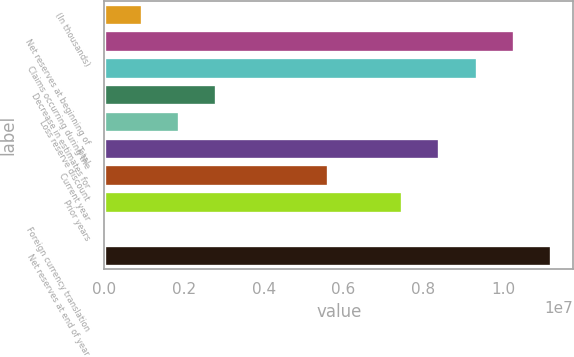<chart> <loc_0><loc_0><loc_500><loc_500><bar_chart><fcel>(In thousands)<fcel>Net reserves at beginning of<fcel>Claims occurring during the<fcel>Decrease in estimates for<fcel>Loss reserve discount<fcel>Total<fcel>Current year<fcel>Prior years<fcel>Foreign currency translation<fcel>Net reserves at end of year<nl><fcel>934815<fcel>1.02707e+07<fcel>9.33713e+06<fcel>2.802e+06<fcel>1.86841e+06<fcel>8.40354e+06<fcel>5.60277e+06<fcel>7.46995e+06<fcel>1224<fcel>1.12043e+07<nl></chart> 